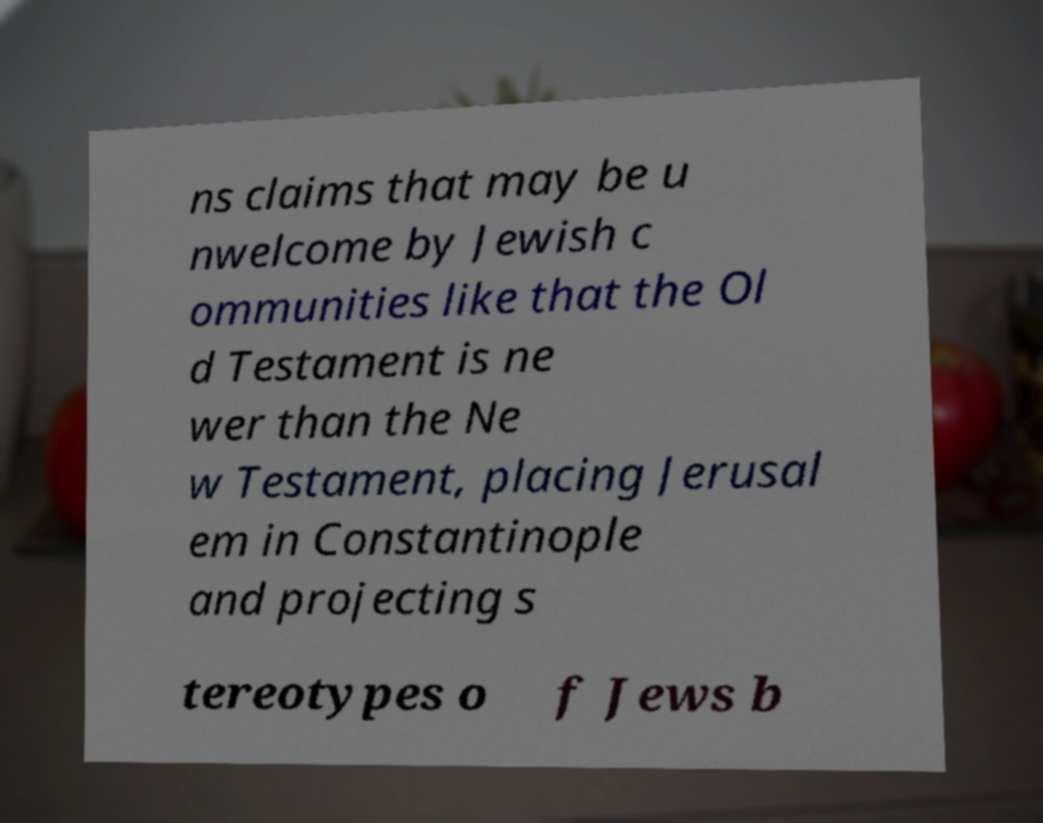Could you extract and type out the text from this image? ns claims that may be u nwelcome by Jewish c ommunities like that the Ol d Testament is ne wer than the Ne w Testament, placing Jerusal em in Constantinople and projecting s tereotypes o f Jews b 